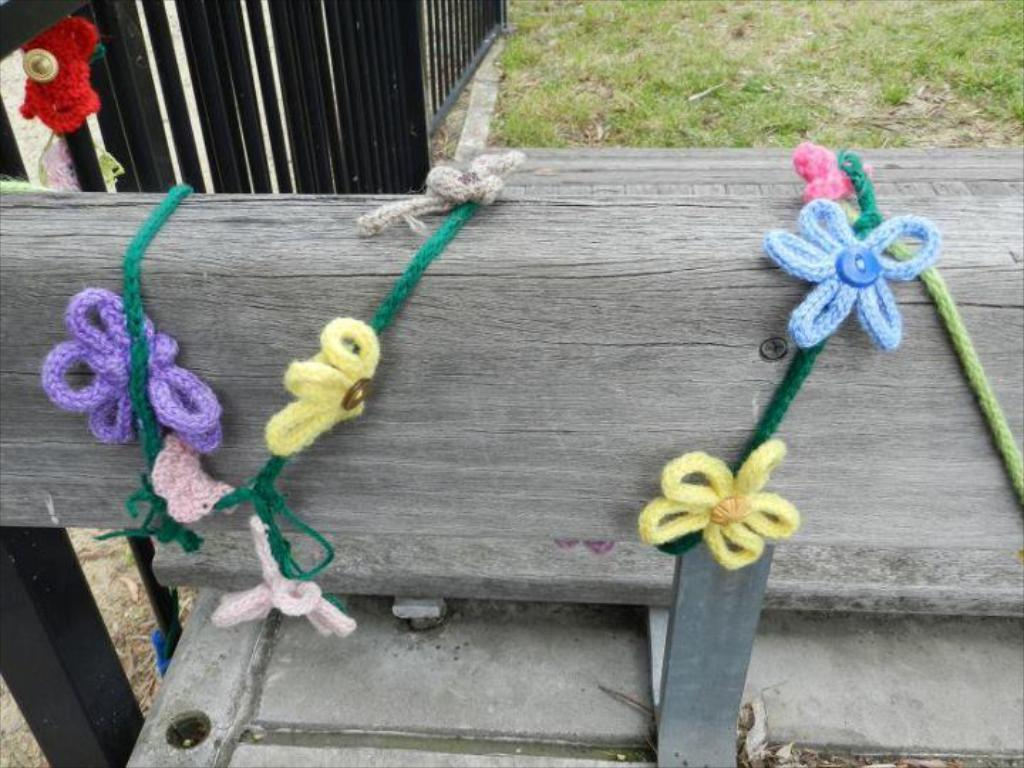What type of terrain is visible in the image? There is a grassy land in the image. What is the purpose of the fencing in the image? The purpose of the fencing is not explicitly stated, but it could be used for enclosing or separating areas. What is the wooden object in the image? There is a wooden object in the image, but its specific purpose or function is not clear. What is attached to the wooden object? There are threads tied to the wooden object. What type of snails can be seen crawling on the texture of the wooden object? There are no snails visible in the image, and the wooden object's texture is not described. 